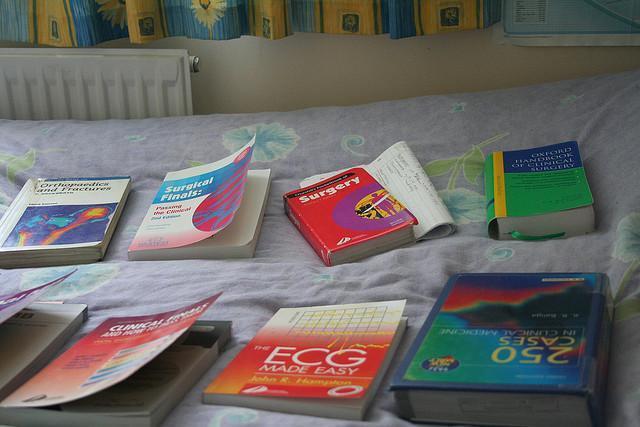How many books can be seen?
Give a very brief answer. 8. How many people have on white shorts?
Give a very brief answer. 0. 